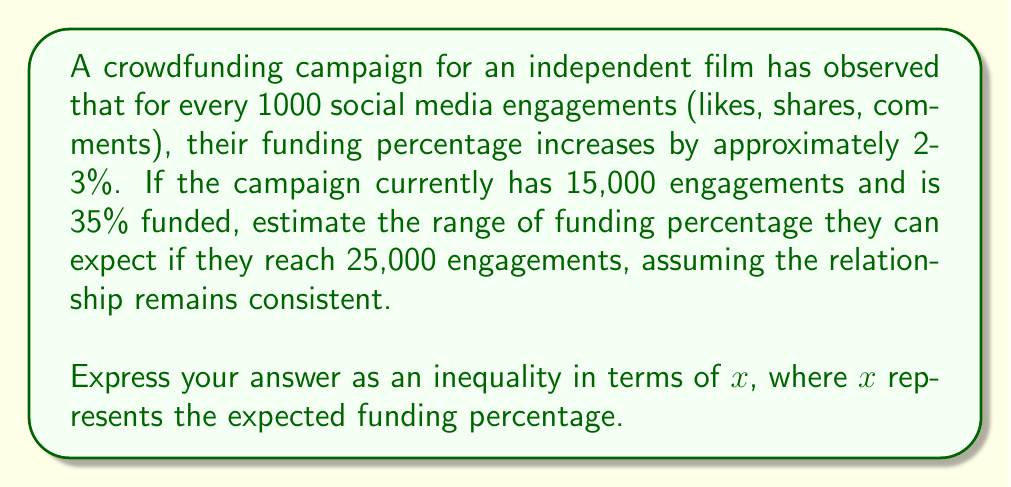Solve this math problem. Let's approach this step-by-step:

1) First, we need to calculate the increase in engagements:
   $25,000 - 15,000 = 10,000$ engagements

2) We know that every 1000 engagements increases funding by 2-3%. So for 10,000 engagements:
   Lower bound: $10 \times 2\% = 20\%$
   Upper bound: $10 \times 3\% = 30\%$

3) The current funding is 35%. We need to add the potential increase to this:
   Lower bound: $35\% + 20\% = 55\%$
   Upper bound: $35\% + 30\% = 65\%$

4) Therefore, we can expect the funding percentage to be between 55% and 65%.

5) Expressing this as an inequality in terms of $x$:

   $$55 \leq x \leq 65$$

This inequality represents the range of expected funding percentages when the campaign reaches 25,000 engagements.
Answer: $55 \leq x \leq 65$, where $x$ is the expected funding percentage. 